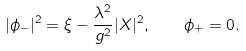Convert formula to latex. <formula><loc_0><loc_0><loc_500><loc_500>| \phi _ { - } | ^ { 2 } = \xi - \frac { \lambda ^ { 2 } } { g ^ { 2 } } | X | ^ { 2 } , \quad \phi _ { + } = 0 .</formula> 